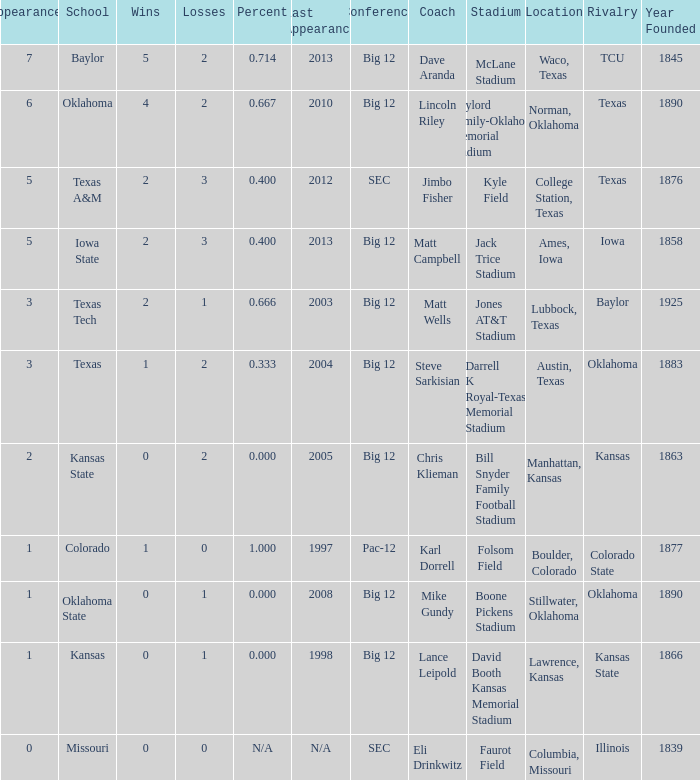Parse the table in full. {'header': ['Appearances', 'School', 'Wins', 'Losses', 'Percent', 'Last Appearance', 'Conference', 'Coach', 'Stadium', 'Location', 'Rivalry', 'Year Founded'], 'rows': [['7', 'Baylor', '5', '2', '0.714', '2013', 'Big 12', 'Dave Aranda', 'McLane Stadium', 'Waco, Texas', 'TCU', '1845'], ['6', 'Oklahoma', '4', '2', '0.667', '2010', 'Big 12', 'Lincoln Riley', 'Gaylord Family-Oklahoma Memorial Stadium', 'Norman, Oklahoma', 'Texas', '1890'], ['5', 'Texas A&M', '2', '3', '0.400', '2012', 'SEC', 'Jimbo Fisher', 'Kyle Field', 'College Station, Texas', 'Texas', '1876'], ['5', 'Iowa State', '2', '3', '0.400', '2013', 'Big 12', 'Matt Campbell', 'Jack Trice Stadium', 'Ames, Iowa', 'Iowa', '1858'], ['3', 'Texas Tech', '2', '1', '0.666', '2003', 'Big 12', 'Matt Wells', 'Jones AT&T Stadium', 'Lubbock, Texas', 'Baylor', '1925'], ['3', 'Texas', '1', '2', '0.333', '2004', 'Big 12', 'Steve Sarkisian', 'Darrell K Royal-Texas Memorial Stadium', 'Austin, Texas', 'Oklahoma', '1883'], ['2', 'Kansas State', '0', '2', '0.000', '2005', 'Big 12', 'Chris Klieman', 'Bill Snyder Family Football Stadium', 'Manhattan, Kansas', 'Kansas', '1863'], ['1', 'Colorado', '1', '0', '1.000', '1997', 'Pac-12', 'Karl Dorrell', 'Folsom Field', 'Boulder, Colorado', 'Colorado State', '1877'], ['1', 'Oklahoma State', '0', '1', '0.000', '2008', 'Big 12', 'Mike Gundy', 'Boone Pickens Stadium', 'Stillwater, Oklahoma', 'Oklahoma', '1890'], ['1', 'Kansas', '0', '1', '0.000', '1998', 'Big 12', 'Lance Leipold', 'David Booth Kansas Memorial Stadium', 'Lawrence, Kansas', 'Kansas State', '1866'], ['0', 'Missouri', '0', '0', 'N/A', 'N/A', 'SEC', 'Eli Drinkwitz', 'Faurot Field', 'Columbia, Missouri', 'Illinois', '1839']]} How many wins did Baylor have?  1.0. 